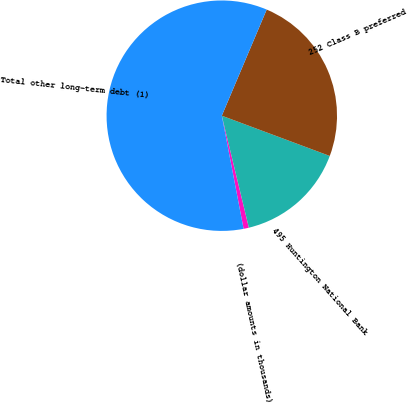<chart> <loc_0><loc_0><loc_500><loc_500><pie_chart><fcel>(dollar amounts in thousands)<fcel>495 Huntington National Bank<fcel>252 Class B preferred<fcel>Total other long-term debt (1)<nl><fcel>0.75%<fcel>15.54%<fcel>24.31%<fcel>59.39%<nl></chart> 